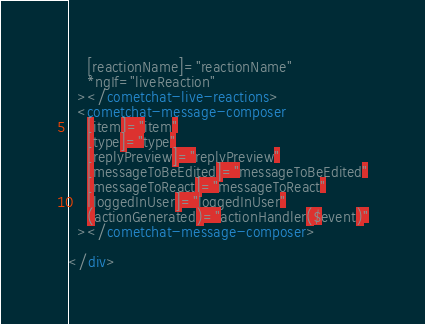<code> <loc_0><loc_0><loc_500><loc_500><_HTML_>    [reactionName]="reactionName"
    *ngIf="liveReaction"
  ></cometchat-live-reactions>
  <cometchat-message-composer
    [item]="item"
    [type]="type"
    [replyPreview]="replyPreview"
    [messageToBeEdited]="messageToBeEdited"
    [messageToReact]="messageToReact"
    [loggedInUser]="loggedInUser"
    (actionGenerated)="actionHandler($event)"
  ></cometchat-message-composer>

</div>

</code> 